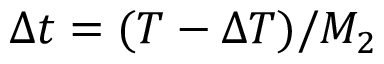<formula> <loc_0><loc_0><loc_500><loc_500>\Delta t = ( T - \Delta T ) / M _ { 2 }</formula> 